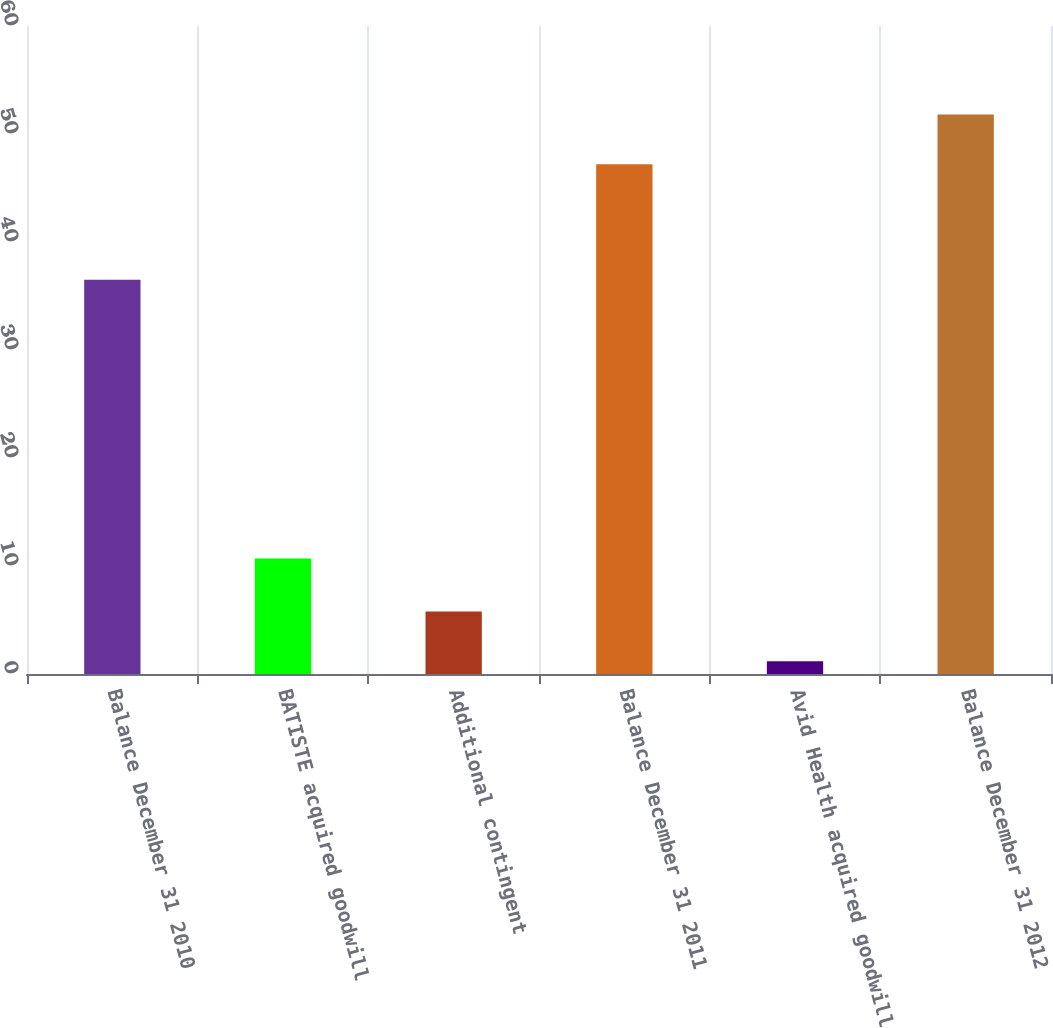Convert chart to OTSL. <chart><loc_0><loc_0><loc_500><loc_500><bar_chart><fcel>Balance December 31 2010<fcel>BATISTE acquired goodwill<fcel>Additional contingent<fcel>Balance December 31 2011<fcel>Avid Health acquired goodwill<fcel>Balance December 31 2012<nl><fcel>36.5<fcel>10.7<fcel>5.78<fcel>47.2<fcel>1.18<fcel>51.8<nl></chart> 